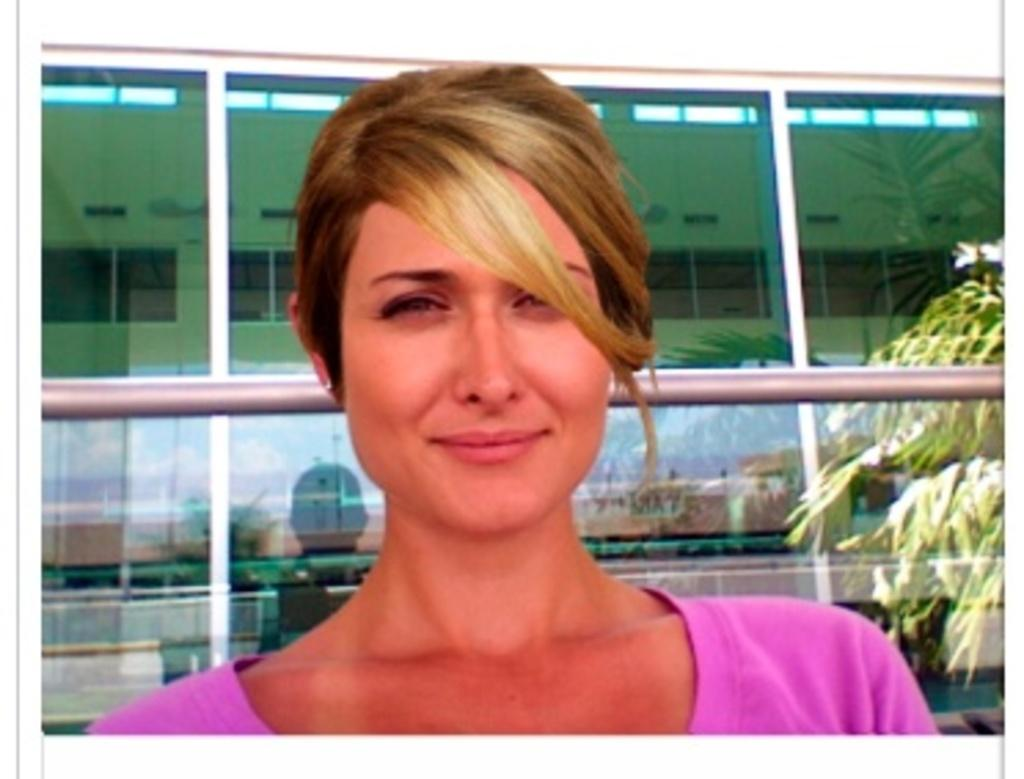Who is the main subject in the foreground of the image? There is a woman in the foreground of the image. What can be seen in the background of the image? There is a building in the background of the image. What type of architectural feature is present in the background? There are glass doors in the background of the image. What do the glass doors reflect in the image? The glass doors provide a reflection of plants and some objects. What type of authority figure is present in the image? There is no authority figure present in the image. What type of humor can be seen in the image? There is no humor depicted in the image. 